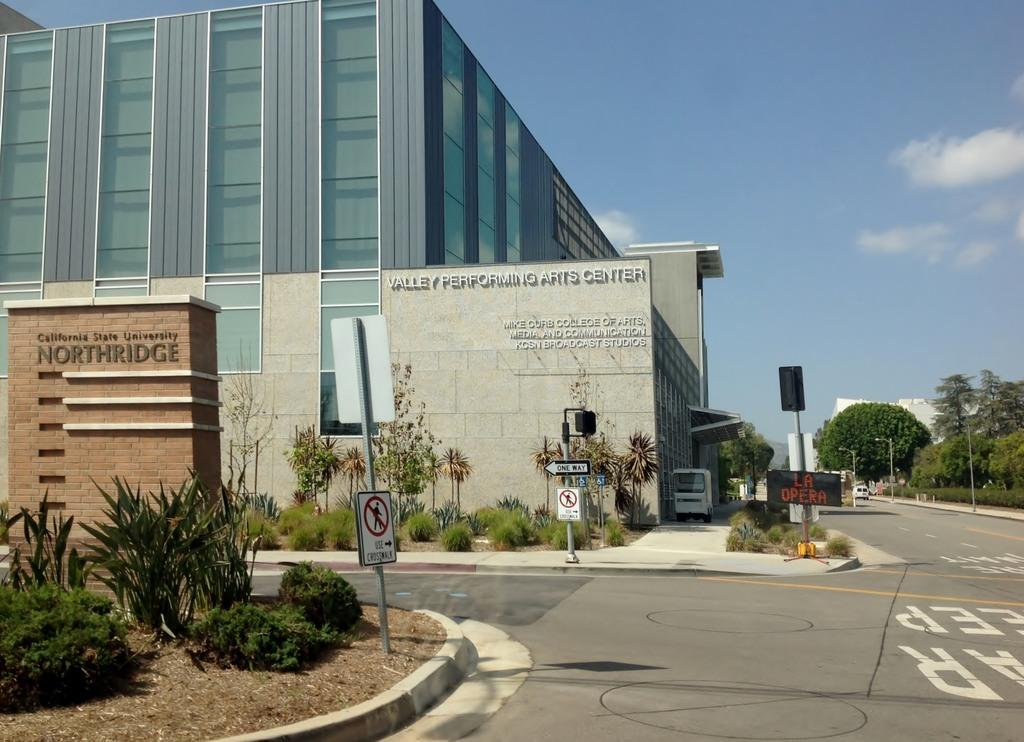What type of surface can be seen in the image? There is a road in the image. What type of vegetation is present in the image? There are plants, grass, and trees in the image. What type of terrain can be seen in the image? There is sand in the image. What type of structures are visible in the image? There are buildings in the image. What can be seen on the walls of the buildings in the image? There is text on the walls in the image. What part of the natural environment is visible in the image? The sky is visible in the image. What type of fruit is being sold by the dinosaurs in the image? There are no dinosaurs present in the image, and therefore no fruit is being sold by them. What question is being asked by the person in the image? There is no person asking a question in the image. 